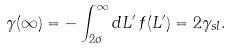Convert formula to latex. <formula><loc_0><loc_0><loc_500><loc_500>\gamma ( \infty ) = - \int _ { 2 \sigma } ^ { \infty } d L ^ { \prime } \, f ( L ^ { \prime } ) = 2 \gamma _ { s l } .</formula> 